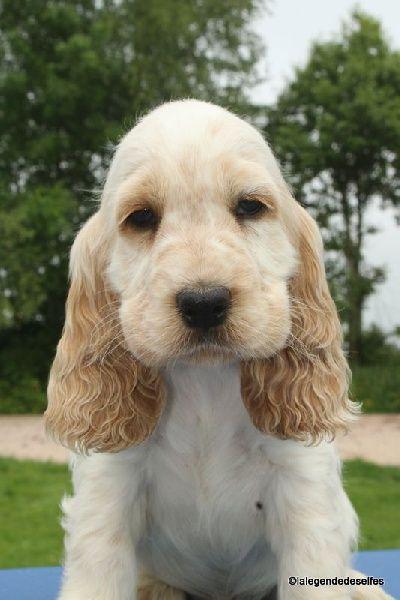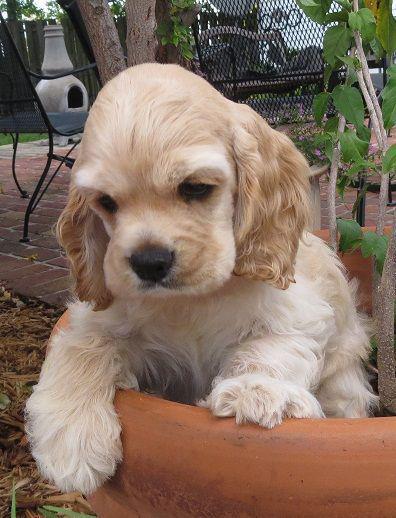The first image is the image on the left, the second image is the image on the right. Considering the images on both sides, is "In one of the two images the dog is being held in someone's hands." valid? Answer yes or no. No. The first image is the image on the left, the second image is the image on the right. Analyze the images presented: Is the assertion "A hand is holding one spaniel in the left image, while the right image shows at least one spaniel sitting upright." valid? Answer yes or no. No. 